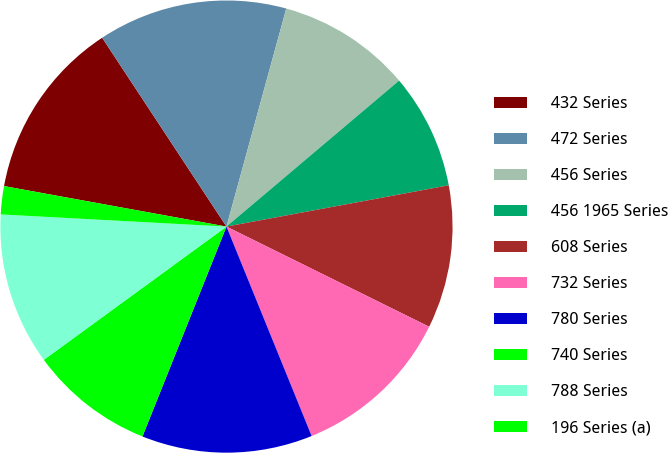<chart> <loc_0><loc_0><loc_500><loc_500><pie_chart><fcel>432 Series<fcel>472 Series<fcel>456 Series<fcel>456 1965 Series<fcel>608 Series<fcel>732 Series<fcel>780 Series<fcel>740 Series<fcel>788 Series<fcel>196 Series (a)<nl><fcel>12.87%<fcel>13.53%<fcel>9.57%<fcel>8.25%<fcel>10.23%<fcel>11.55%<fcel>12.21%<fcel>8.91%<fcel>10.89%<fcel>2.01%<nl></chart> 